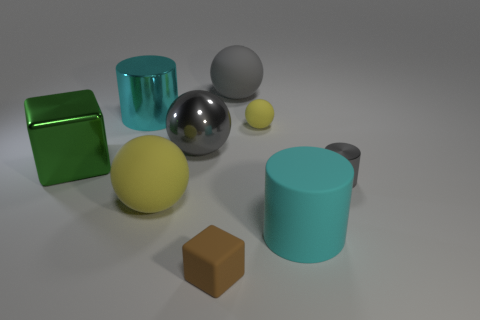There is a large matte cylinder; how many large gray spheres are on the right side of it? Upon reviewing the image, there are no large gray spheres located on the right side of the large matte cylinder, hence the count is zero. The configuration includes various geometric shapes with different colors and finishes, contributing to a visually diverse arrangement. 